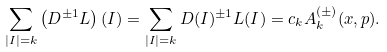<formula> <loc_0><loc_0><loc_500><loc_500>\sum _ { | I | = k } \left ( D ^ { \pm 1 } L \right ) ( I ) = \sum _ { | I | = k } D ( I ) ^ { \pm 1 } L ( I ) = c _ { k } A _ { k } ^ { ( \pm ) } ( x , p ) .</formula> 